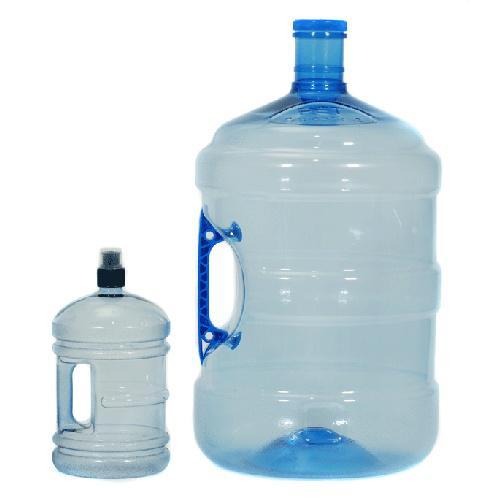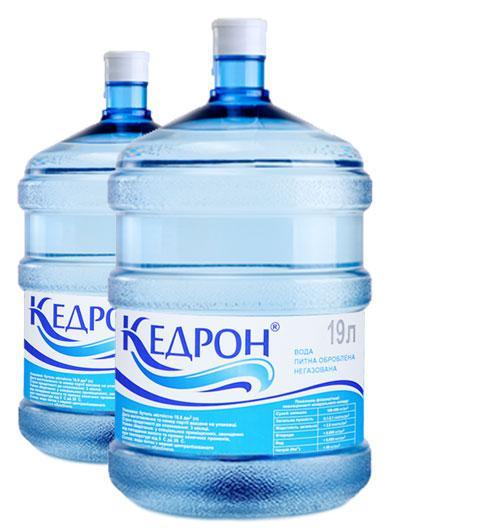The first image is the image on the left, the second image is the image on the right. For the images shown, is this caption "An image includes a smaller handled jug next to a larger water jug with handle visible." true? Answer yes or no. Yes. The first image is the image on the left, the second image is the image on the right. For the images shown, is this caption "Exactly four blue tinted plastic bottles are shown, two with a hand grip in the side of the bottle, and two with no grips." true? Answer yes or no. Yes. 